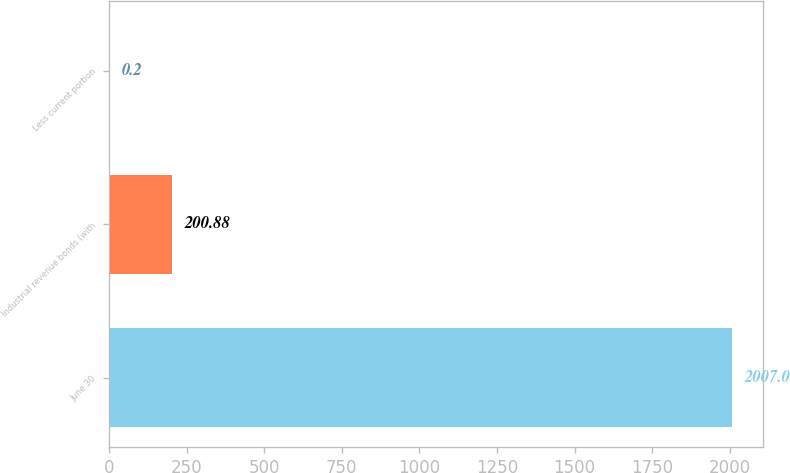Convert chart. <chart><loc_0><loc_0><loc_500><loc_500><bar_chart><fcel>June 30<fcel>Industrial revenue bonds (with<fcel>Less current portion<nl><fcel>2007<fcel>200.88<fcel>0.2<nl></chart> 